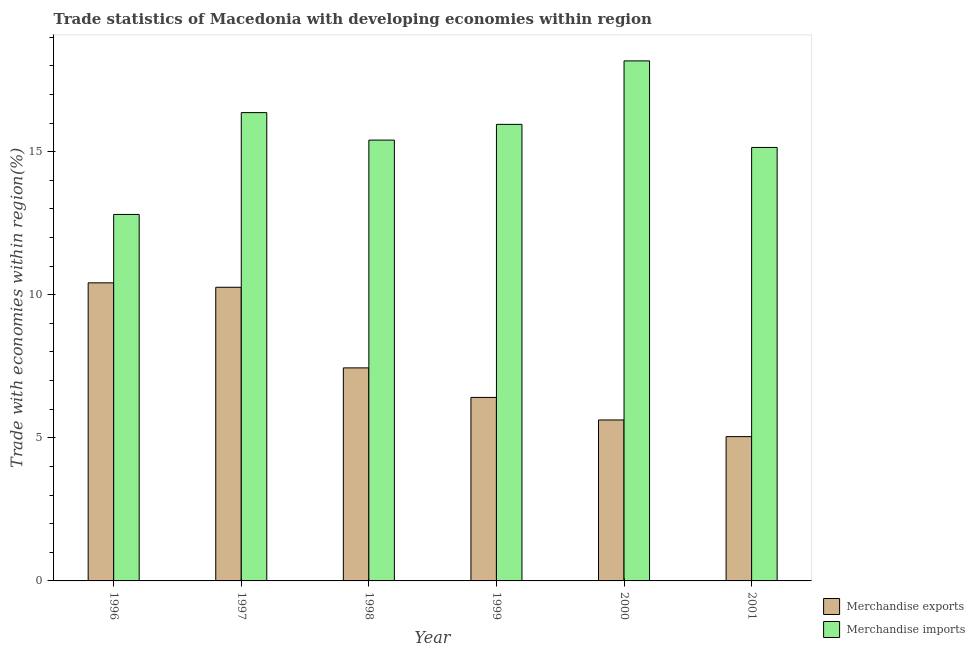In how many cases, is the number of bars for a given year not equal to the number of legend labels?
Your response must be concise. 0. What is the merchandise imports in 2001?
Your answer should be very brief. 15.15. Across all years, what is the maximum merchandise imports?
Provide a succinct answer. 18.17. Across all years, what is the minimum merchandise imports?
Provide a short and direct response. 12.81. In which year was the merchandise imports maximum?
Offer a terse response. 2000. In which year was the merchandise imports minimum?
Provide a succinct answer. 1996. What is the total merchandise exports in the graph?
Make the answer very short. 45.2. What is the difference between the merchandise exports in 1996 and that in 1999?
Keep it short and to the point. 4. What is the difference between the merchandise imports in 1997 and the merchandise exports in 2001?
Provide a short and direct response. 1.22. What is the average merchandise exports per year?
Give a very brief answer. 7.53. What is the ratio of the merchandise exports in 1996 to that in 2001?
Keep it short and to the point. 2.07. Is the difference between the merchandise imports in 1996 and 2001 greater than the difference between the merchandise exports in 1996 and 2001?
Your response must be concise. No. What is the difference between the highest and the second highest merchandise exports?
Your answer should be very brief. 0.15. What is the difference between the highest and the lowest merchandise imports?
Provide a succinct answer. 5.37. Is the sum of the merchandise imports in 1996 and 2000 greater than the maximum merchandise exports across all years?
Provide a succinct answer. Yes. What does the 1st bar from the right in 1999 represents?
Keep it short and to the point. Merchandise imports. How many bars are there?
Offer a very short reply. 12. How many years are there in the graph?
Your answer should be very brief. 6. What is the difference between two consecutive major ticks on the Y-axis?
Provide a short and direct response. 5. How many legend labels are there?
Keep it short and to the point. 2. How are the legend labels stacked?
Your answer should be compact. Vertical. What is the title of the graph?
Offer a very short reply. Trade statistics of Macedonia with developing economies within region. What is the label or title of the Y-axis?
Provide a short and direct response. Trade with economies within region(%). What is the Trade with economies within region(%) of Merchandise exports in 1996?
Ensure brevity in your answer.  10.42. What is the Trade with economies within region(%) in Merchandise imports in 1996?
Provide a short and direct response. 12.81. What is the Trade with economies within region(%) in Merchandise exports in 1997?
Offer a terse response. 10.26. What is the Trade with economies within region(%) in Merchandise imports in 1997?
Your response must be concise. 16.36. What is the Trade with economies within region(%) of Merchandise exports in 1998?
Your answer should be very brief. 7.44. What is the Trade with economies within region(%) of Merchandise imports in 1998?
Keep it short and to the point. 15.4. What is the Trade with economies within region(%) of Merchandise exports in 1999?
Make the answer very short. 6.41. What is the Trade with economies within region(%) in Merchandise imports in 1999?
Provide a succinct answer. 15.95. What is the Trade with economies within region(%) in Merchandise exports in 2000?
Keep it short and to the point. 5.62. What is the Trade with economies within region(%) of Merchandise imports in 2000?
Your answer should be compact. 18.17. What is the Trade with economies within region(%) of Merchandise exports in 2001?
Make the answer very short. 5.04. What is the Trade with economies within region(%) of Merchandise imports in 2001?
Provide a short and direct response. 15.15. Across all years, what is the maximum Trade with economies within region(%) of Merchandise exports?
Offer a terse response. 10.42. Across all years, what is the maximum Trade with economies within region(%) of Merchandise imports?
Offer a terse response. 18.17. Across all years, what is the minimum Trade with economies within region(%) of Merchandise exports?
Provide a succinct answer. 5.04. Across all years, what is the minimum Trade with economies within region(%) in Merchandise imports?
Your answer should be very brief. 12.81. What is the total Trade with economies within region(%) of Merchandise exports in the graph?
Provide a short and direct response. 45.2. What is the total Trade with economies within region(%) in Merchandise imports in the graph?
Provide a short and direct response. 93.85. What is the difference between the Trade with economies within region(%) in Merchandise exports in 1996 and that in 1997?
Your answer should be compact. 0.15. What is the difference between the Trade with economies within region(%) of Merchandise imports in 1996 and that in 1997?
Give a very brief answer. -3.56. What is the difference between the Trade with economies within region(%) of Merchandise exports in 1996 and that in 1998?
Make the answer very short. 2.97. What is the difference between the Trade with economies within region(%) in Merchandise imports in 1996 and that in 1998?
Your response must be concise. -2.6. What is the difference between the Trade with economies within region(%) of Merchandise exports in 1996 and that in 1999?
Provide a succinct answer. 4. What is the difference between the Trade with economies within region(%) in Merchandise imports in 1996 and that in 1999?
Offer a terse response. -3.15. What is the difference between the Trade with economies within region(%) of Merchandise exports in 1996 and that in 2000?
Your response must be concise. 4.79. What is the difference between the Trade with economies within region(%) in Merchandise imports in 1996 and that in 2000?
Offer a terse response. -5.37. What is the difference between the Trade with economies within region(%) in Merchandise exports in 1996 and that in 2001?
Offer a very short reply. 5.37. What is the difference between the Trade with economies within region(%) in Merchandise imports in 1996 and that in 2001?
Your answer should be very brief. -2.34. What is the difference between the Trade with economies within region(%) in Merchandise exports in 1997 and that in 1998?
Make the answer very short. 2.82. What is the difference between the Trade with economies within region(%) in Merchandise imports in 1997 and that in 1998?
Offer a terse response. 0.96. What is the difference between the Trade with economies within region(%) in Merchandise exports in 1997 and that in 1999?
Offer a very short reply. 3.85. What is the difference between the Trade with economies within region(%) of Merchandise imports in 1997 and that in 1999?
Keep it short and to the point. 0.41. What is the difference between the Trade with economies within region(%) of Merchandise exports in 1997 and that in 2000?
Provide a short and direct response. 4.64. What is the difference between the Trade with economies within region(%) in Merchandise imports in 1997 and that in 2000?
Ensure brevity in your answer.  -1.81. What is the difference between the Trade with economies within region(%) in Merchandise exports in 1997 and that in 2001?
Offer a very short reply. 5.22. What is the difference between the Trade with economies within region(%) of Merchandise imports in 1997 and that in 2001?
Keep it short and to the point. 1.22. What is the difference between the Trade with economies within region(%) in Merchandise exports in 1998 and that in 1999?
Keep it short and to the point. 1.03. What is the difference between the Trade with economies within region(%) in Merchandise imports in 1998 and that in 1999?
Your response must be concise. -0.55. What is the difference between the Trade with economies within region(%) of Merchandise exports in 1998 and that in 2000?
Provide a succinct answer. 1.82. What is the difference between the Trade with economies within region(%) in Merchandise imports in 1998 and that in 2000?
Offer a very short reply. -2.77. What is the difference between the Trade with economies within region(%) of Merchandise exports in 1998 and that in 2001?
Provide a short and direct response. 2.4. What is the difference between the Trade with economies within region(%) of Merchandise imports in 1998 and that in 2001?
Give a very brief answer. 0.26. What is the difference between the Trade with economies within region(%) of Merchandise exports in 1999 and that in 2000?
Keep it short and to the point. 0.79. What is the difference between the Trade with economies within region(%) of Merchandise imports in 1999 and that in 2000?
Your response must be concise. -2.22. What is the difference between the Trade with economies within region(%) of Merchandise exports in 1999 and that in 2001?
Offer a very short reply. 1.37. What is the difference between the Trade with economies within region(%) in Merchandise imports in 1999 and that in 2001?
Your answer should be very brief. 0.81. What is the difference between the Trade with economies within region(%) in Merchandise exports in 2000 and that in 2001?
Provide a succinct answer. 0.58. What is the difference between the Trade with economies within region(%) in Merchandise imports in 2000 and that in 2001?
Provide a short and direct response. 3.03. What is the difference between the Trade with economies within region(%) in Merchandise exports in 1996 and the Trade with economies within region(%) in Merchandise imports in 1997?
Your answer should be very brief. -5.95. What is the difference between the Trade with economies within region(%) in Merchandise exports in 1996 and the Trade with economies within region(%) in Merchandise imports in 1998?
Offer a terse response. -4.99. What is the difference between the Trade with economies within region(%) of Merchandise exports in 1996 and the Trade with economies within region(%) of Merchandise imports in 1999?
Provide a succinct answer. -5.54. What is the difference between the Trade with economies within region(%) in Merchandise exports in 1996 and the Trade with economies within region(%) in Merchandise imports in 2000?
Provide a short and direct response. -7.76. What is the difference between the Trade with economies within region(%) in Merchandise exports in 1996 and the Trade with economies within region(%) in Merchandise imports in 2001?
Give a very brief answer. -4.73. What is the difference between the Trade with economies within region(%) of Merchandise exports in 1997 and the Trade with economies within region(%) of Merchandise imports in 1998?
Provide a succinct answer. -5.14. What is the difference between the Trade with economies within region(%) in Merchandise exports in 1997 and the Trade with economies within region(%) in Merchandise imports in 1999?
Ensure brevity in your answer.  -5.69. What is the difference between the Trade with economies within region(%) in Merchandise exports in 1997 and the Trade with economies within region(%) in Merchandise imports in 2000?
Make the answer very short. -7.91. What is the difference between the Trade with economies within region(%) in Merchandise exports in 1997 and the Trade with economies within region(%) in Merchandise imports in 2001?
Your response must be concise. -4.89. What is the difference between the Trade with economies within region(%) of Merchandise exports in 1998 and the Trade with economies within region(%) of Merchandise imports in 1999?
Your answer should be compact. -8.51. What is the difference between the Trade with economies within region(%) of Merchandise exports in 1998 and the Trade with economies within region(%) of Merchandise imports in 2000?
Provide a short and direct response. -10.73. What is the difference between the Trade with economies within region(%) in Merchandise exports in 1998 and the Trade with economies within region(%) in Merchandise imports in 2001?
Provide a succinct answer. -7.7. What is the difference between the Trade with economies within region(%) of Merchandise exports in 1999 and the Trade with economies within region(%) of Merchandise imports in 2000?
Provide a short and direct response. -11.76. What is the difference between the Trade with economies within region(%) of Merchandise exports in 1999 and the Trade with economies within region(%) of Merchandise imports in 2001?
Ensure brevity in your answer.  -8.73. What is the difference between the Trade with economies within region(%) of Merchandise exports in 2000 and the Trade with economies within region(%) of Merchandise imports in 2001?
Your answer should be very brief. -9.52. What is the average Trade with economies within region(%) in Merchandise exports per year?
Offer a terse response. 7.53. What is the average Trade with economies within region(%) of Merchandise imports per year?
Keep it short and to the point. 15.64. In the year 1996, what is the difference between the Trade with economies within region(%) in Merchandise exports and Trade with economies within region(%) in Merchandise imports?
Provide a short and direct response. -2.39. In the year 1997, what is the difference between the Trade with economies within region(%) of Merchandise exports and Trade with economies within region(%) of Merchandise imports?
Offer a very short reply. -6.1. In the year 1998, what is the difference between the Trade with economies within region(%) of Merchandise exports and Trade with economies within region(%) of Merchandise imports?
Offer a terse response. -7.96. In the year 1999, what is the difference between the Trade with economies within region(%) of Merchandise exports and Trade with economies within region(%) of Merchandise imports?
Offer a very short reply. -9.54. In the year 2000, what is the difference between the Trade with economies within region(%) in Merchandise exports and Trade with economies within region(%) in Merchandise imports?
Your response must be concise. -12.55. In the year 2001, what is the difference between the Trade with economies within region(%) in Merchandise exports and Trade with economies within region(%) in Merchandise imports?
Give a very brief answer. -10.1. What is the ratio of the Trade with economies within region(%) of Merchandise exports in 1996 to that in 1997?
Provide a succinct answer. 1.02. What is the ratio of the Trade with economies within region(%) in Merchandise imports in 1996 to that in 1997?
Your answer should be compact. 0.78. What is the ratio of the Trade with economies within region(%) in Merchandise exports in 1996 to that in 1998?
Your answer should be very brief. 1.4. What is the ratio of the Trade with economies within region(%) of Merchandise imports in 1996 to that in 1998?
Your response must be concise. 0.83. What is the ratio of the Trade with economies within region(%) in Merchandise exports in 1996 to that in 1999?
Ensure brevity in your answer.  1.62. What is the ratio of the Trade with economies within region(%) of Merchandise imports in 1996 to that in 1999?
Give a very brief answer. 0.8. What is the ratio of the Trade with economies within region(%) of Merchandise exports in 1996 to that in 2000?
Provide a short and direct response. 1.85. What is the ratio of the Trade with economies within region(%) of Merchandise imports in 1996 to that in 2000?
Keep it short and to the point. 0.7. What is the ratio of the Trade with economies within region(%) of Merchandise exports in 1996 to that in 2001?
Provide a succinct answer. 2.07. What is the ratio of the Trade with economies within region(%) in Merchandise imports in 1996 to that in 2001?
Offer a terse response. 0.85. What is the ratio of the Trade with economies within region(%) of Merchandise exports in 1997 to that in 1998?
Provide a succinct answer. 1.38. What is the ratio of the Trade with economies within region(%) in Merchandise imports in 1997 to that in 1998?
Keep it short and to the point. 1.06. What is the ratio of the Trade with economies within region(%) of Merchandise exports in 1997 to that in 1999?
Offer a terse response. 1.6. What is the ratio of the Trade with economies within region(%) of Merchandise imports in 1997 to that in 1999?
Your answer should be very brief. 1.03. What is the ratio of the Trade with economies within region(%) of Merchandise exports in 1997 to that in 2000?
Provide a succinct answer. 1.82. What is the ratio of the Trade with economies within region(%) in Merchandise imports in 1997 to that in 2000?
Provide a succinct answer. 0.9. What is the ratio of the Trade with economies within region(%) in Merchandise exports in 1997 to that in 2001?
Offer a very short reply. 2.03. What is the ratio of the Trade with economies within region(%) of Merchandise imports in 1997 to that in 2001?
Your answer should be compact. 1.08. What is the ratio of the Trade with economies within region(%) of Merchandise exports in 1998 to that in 1999?
Offer a terse response. 1.16. What is the ratio of the Trade with economies within region(%) in Merchandise imports in 1998 to that in 1999?
Make the answer very short. 0.97. What is the ratio of the Trade with economies within region(%) of Merchandise exports in 1998 to that in 2000?
Provide a short and direct response. 1.32. What is the ratio of the Trade with economies within region(%) in Merchandise imports in 1998 to that in 2000?
Offer a very short reply. 0.85. What is the ratio of the Trade with economies within region(%) in Merchandise exports in 1998 to that in 2001?
Ensure brevity in your answer.  1.48. What is the ratio of the Trade with economies within region(%) in Merchandise imports in 1998 to that in 2001?
Offer a terse response. 1.02. What is the ratio of the Trade with economies within region(%) in Merchandise exports in 1999 to that in 2000?
Your answer should be compact. 1.14. What is the ratio of the Trade with economies within region(%) of Merchandise imports in 1999 to that in 2000?
Ensure brevity in your answer.  0.88. What is the ratio of the Trade with economies within region(%) of Merchandise exports in 1999 to that in 2001?
Give a very brief answer. 1.27. What is the ratio of the Trade with economies within region(%) of Merchandise imports in 1999 to that in 2001?
Provide a succinct answer. 1.05. What is the ratio of the Trade with economies within region(%) of Merchandise exports in 2000 to that in 2001?
Your answer should be very brief. 1.12. What is the ratio of the Trade with economies within region(%) in Merchandise imports in 2000 to that in 2001?
Your answer should be very brief. 1.2. What is the difference between the highest and the second highest Trade with economies within region(%) of Merchandise exports?
Ensure brevity in your answer.  0.15. What is the difference between the highest and the second highest Trade with economies within region(%) of Merchandise imports?
Ensure brevity in your answer.  1.81. What is the difference between the highest and the lowest Trade with economies within region(%) in Merchandise exports?
Provide a short and direct response. 5.37. What is the difference between the highest and the lowest Trade with economies within region(%) in Merchandise imports?
Offer a very short reply. 5.37. 